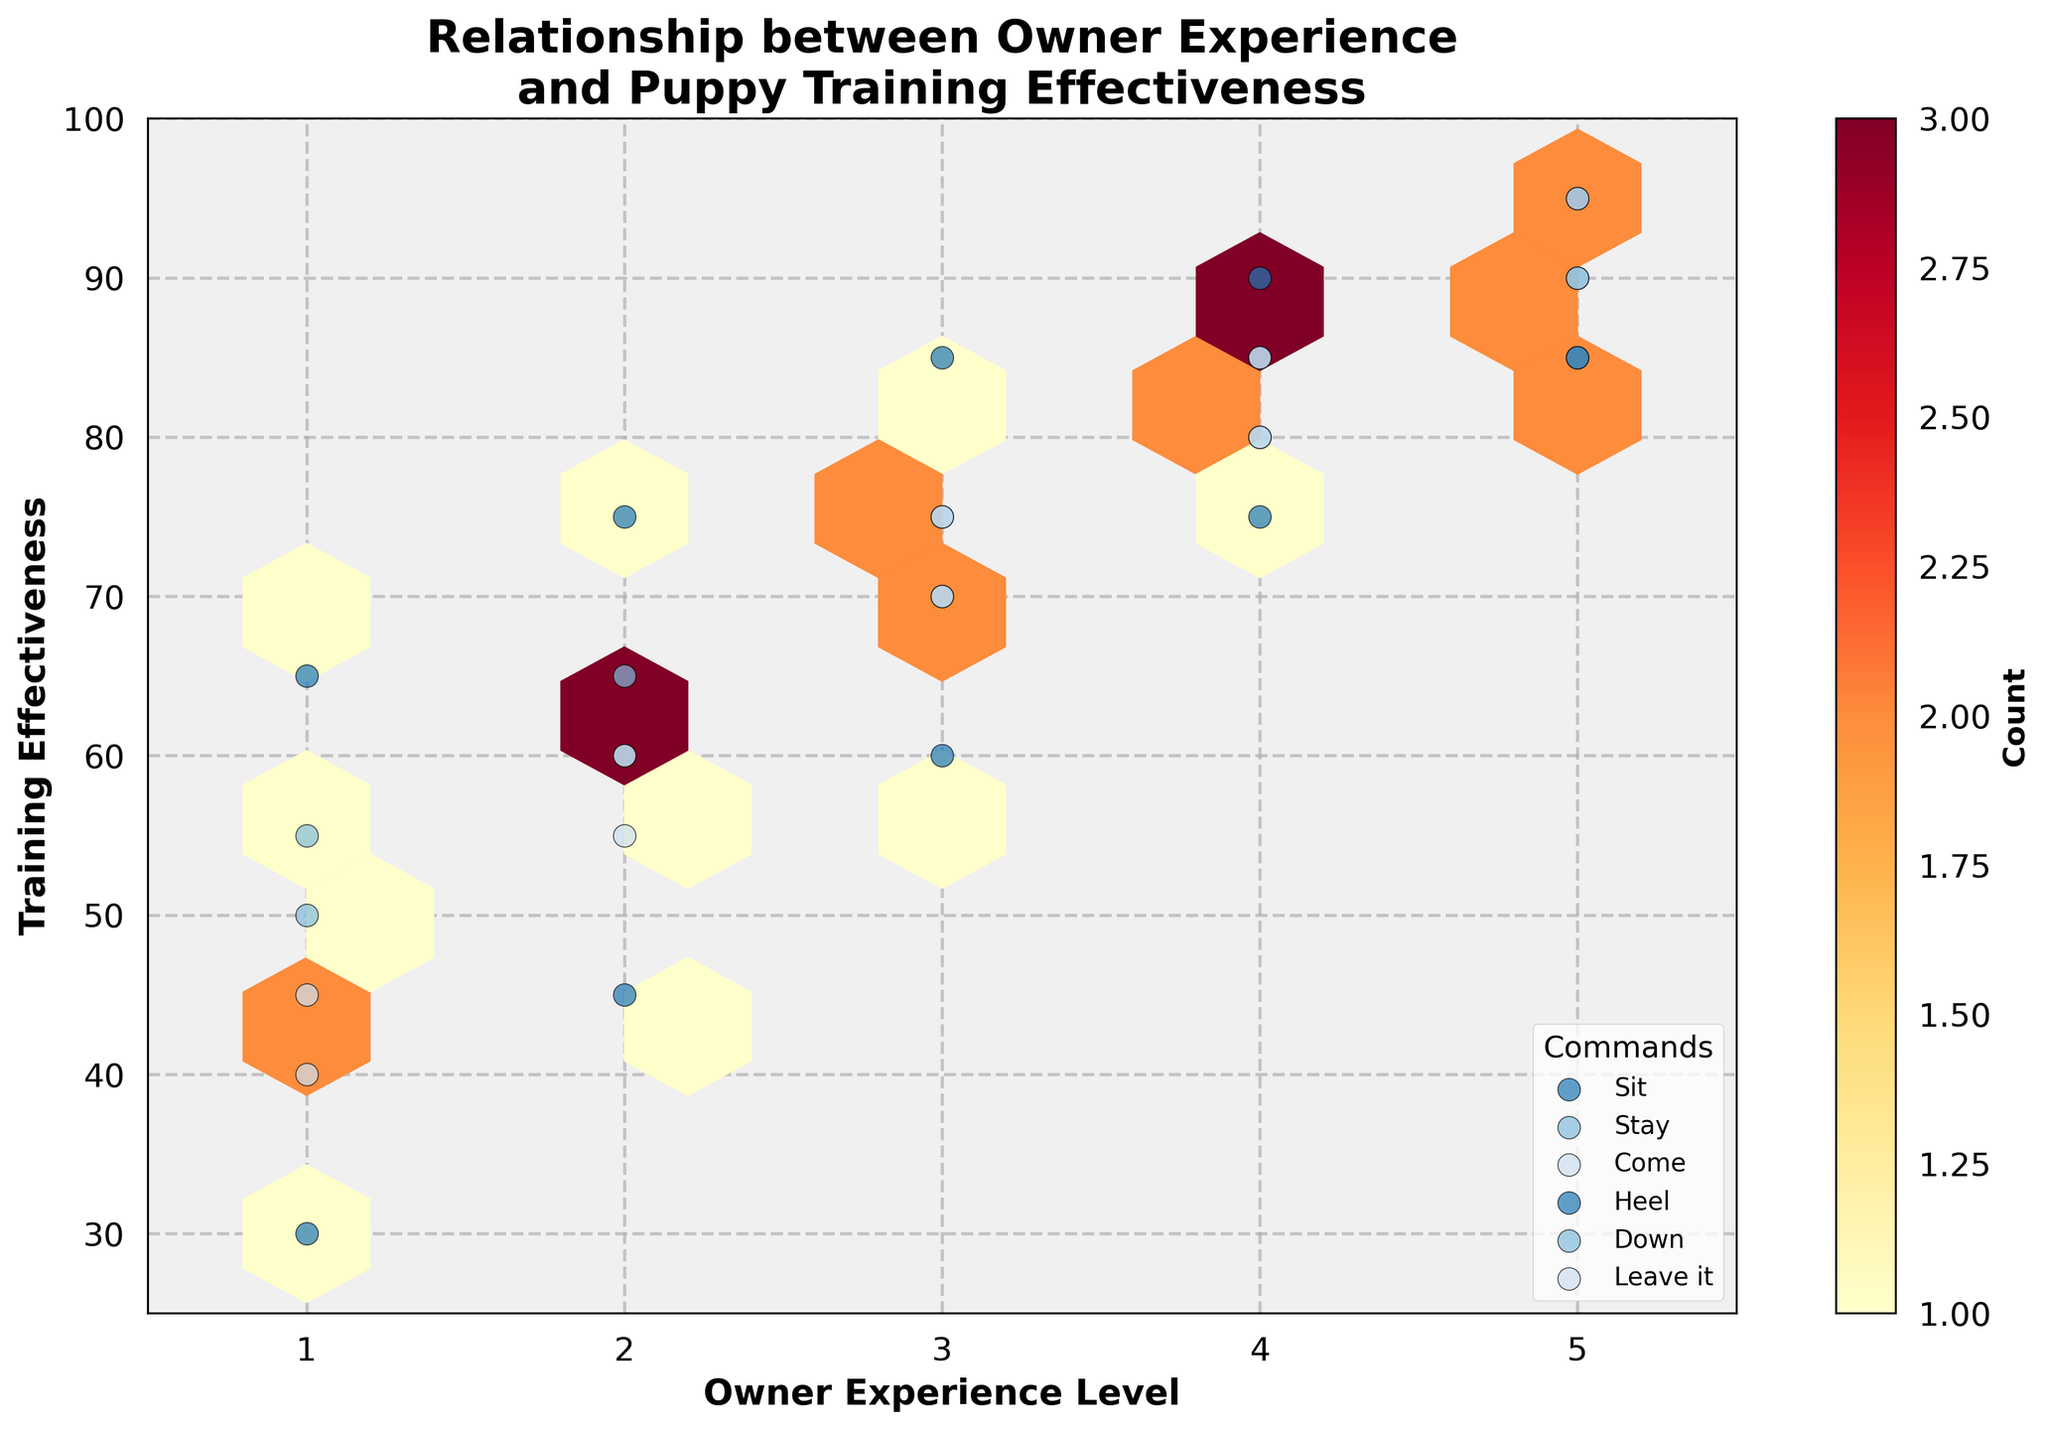How many unique commands are displayed in the plot? The legend shows the different unique commands included in the data. By counting the distinct labels in the legend, we can determine the number of unique commands represented in the plot.
Answer: 6 What is the title of the plot? The title is displayed at the top of the plot. By reading the text at the top, we can identify the title of the plot.
Answer: Relationship between Owner Experience and Puppy Training Effectiveness Between which ranges are owner experience levels depicted? The x-axis represents owner experience levels. By looking at the lower and upper limits of the x-axis, we can determine the range of owner experience levels.
Answer: 0.5 to 5.5 Which command appears to have the highest training effectiveness values for the most experienced owners? By examining the marked points and their labels on the right side of the plot, particularly at the highest owner experience levels, we can see which command reaches the highest training effectiveness values.
Answer: Sit How does the trend of training effectiveness change with owner experience for the command "Heel"? Observing the distribution and direction of points labeled as "Heel" along the x-axis (owner experience) and y-axis (training effectiveness), we can describe the trend.
Answer: Increases with experience Which command has the lowest training effectiveness for novice owners? By checking the points and respective labels at the lowest end of the x-axis (owner experience level 1), we can see which command has the lowest training effectiveness value.
Answer: Heel Between "Stay" and "Come", which command shows a more significant improvement in training effectiveness from novice to experienced owners? Comparing the slope or change in y-axis values from x=1 to x=5 for both commands will show us which command improves more significantly.
Answer: Come What does the color intensity in the hexbin plot represent? Typically, in hexbin plots, color intensity represents the count or density of points within each bin. The color bar on the right side of the plot indicates this relationship.
Answer: Count For the command "Down", does the training effectiveness ever reach 90 or above? By locating and noting the "Down" points along the y-axis, we check if any of them reach or surpass the 90 mark on the training effectiveness axis.
Answer: Yes What trend is observed in the data points for the "Leave it" command as the owner experience level increases? Observing the "Leave it" points along the plot from lower to higher owner experience levels will reveal if they rise or stay static along the training effectiveness axis.
Answer: Increases 